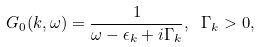Convert formula to latex. <formula><loc_0><loc_0><loc_500><loc_500>G _ { 0 } ( k , \omega ) = \frac { 1 } { \omega - \epsilon _ { k } + i \Gamma _ { k } } , \ \Gamma _ { k } > 0 ,</formula> 